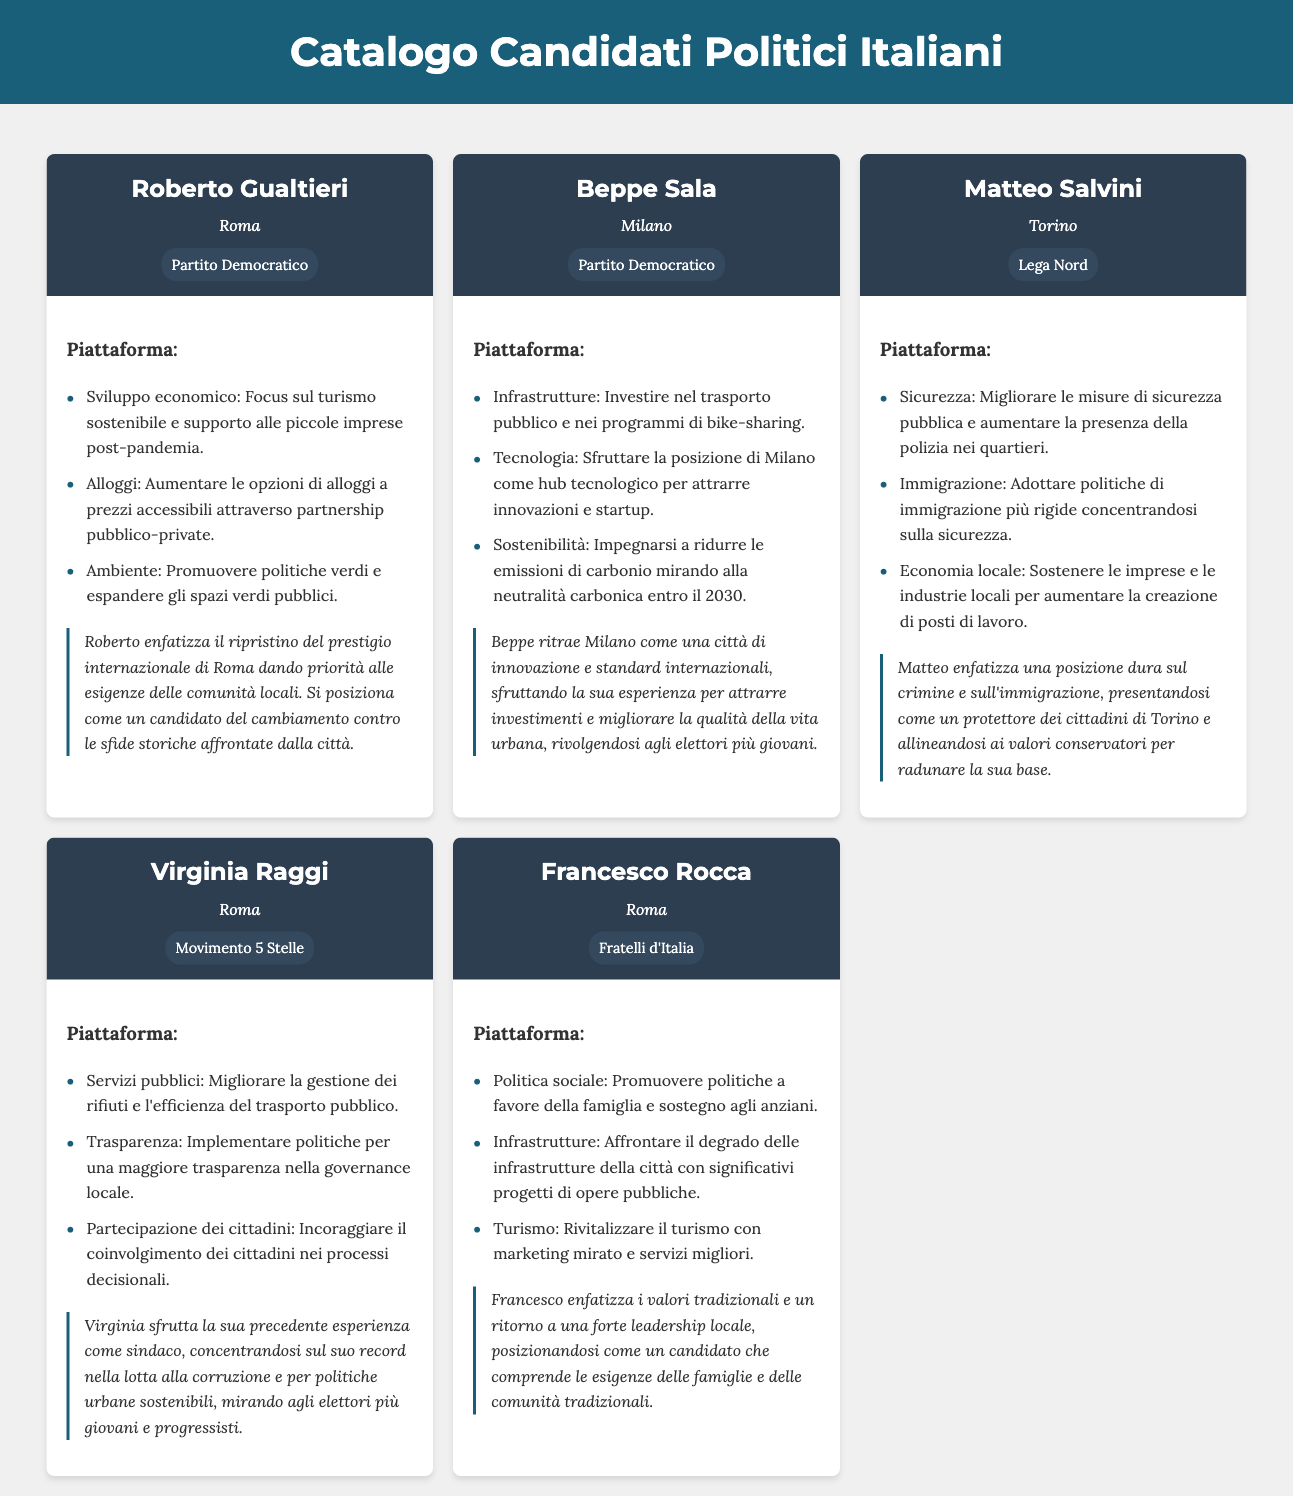What is the name of the candidate running for mayor of Roma? The name of the candidate is mentioned in the candidate headers, with multiple candidates listed for Roma. One of them is Roberto Gualtieri.
Answer: Roberto Gualtieri Which party does Matteo Salvini represent? The party affiliations are provided alongside each candidate's name in the document, specifically under their names.
Answer: Lega Nord What city is Beppe Sala running for mayor? The document specifies the city associated with each candidate in their respective headers.
Answer: Milano What is one of Francesco Rocca's platform points? The platform points are listed in an unordered list for each candidate, providing key topics they are focusing on. One of them mentioned is promoting family-friendly policies.
Answer: Politica sociale How does Virginia Raggi aim to improve public services? The platform of each candidate includes specific strategies, and for Virginia Raggi, it mentions improving waste management and public transport efficiency.
Answer: Migliorare la gestione dei rifiuti e l'efficienza del trasporto pubblico What timeframe is Beppe Sala aiming for carbon neutrality? The document provides specific targets related to sustainability in the platform section for Beppe Sala.
Answer: 2030 What type of messaging does Roberto Gualtieri emphasize? Each candidate's strategic messaging is outlined, detailing how they present themselves, and Gualtieri emphasizes restoring Rome's international prestige.
Answer: Ripristino del prestigio internazionale di Roma Which candidate focuses on security issues in Torino? The candidates' platforms mention specific issues they focus on; one of the candidates discussing security is Matteo Salvini.
Answer: Matteo Salvini 